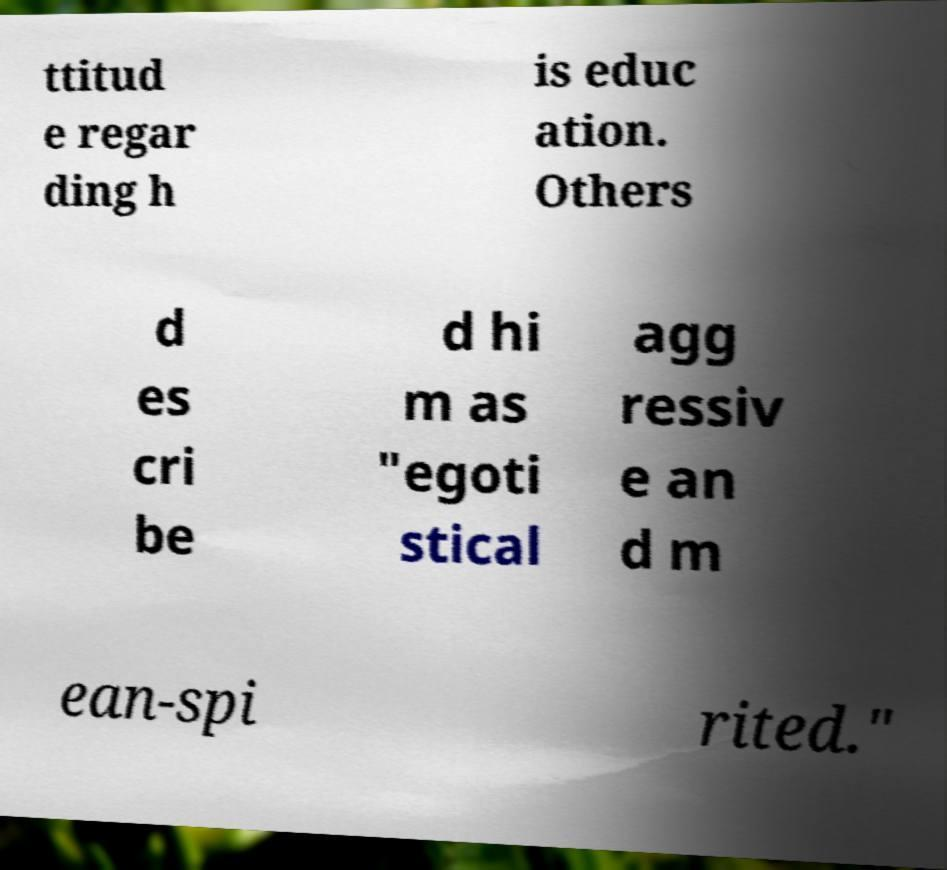Please identify and transcribe the text found in this image. ttitud e regar ding h is educ ation. Others d es cri be d hi m as "egoti stical agg ressiv e an d m ean-spi rited." 